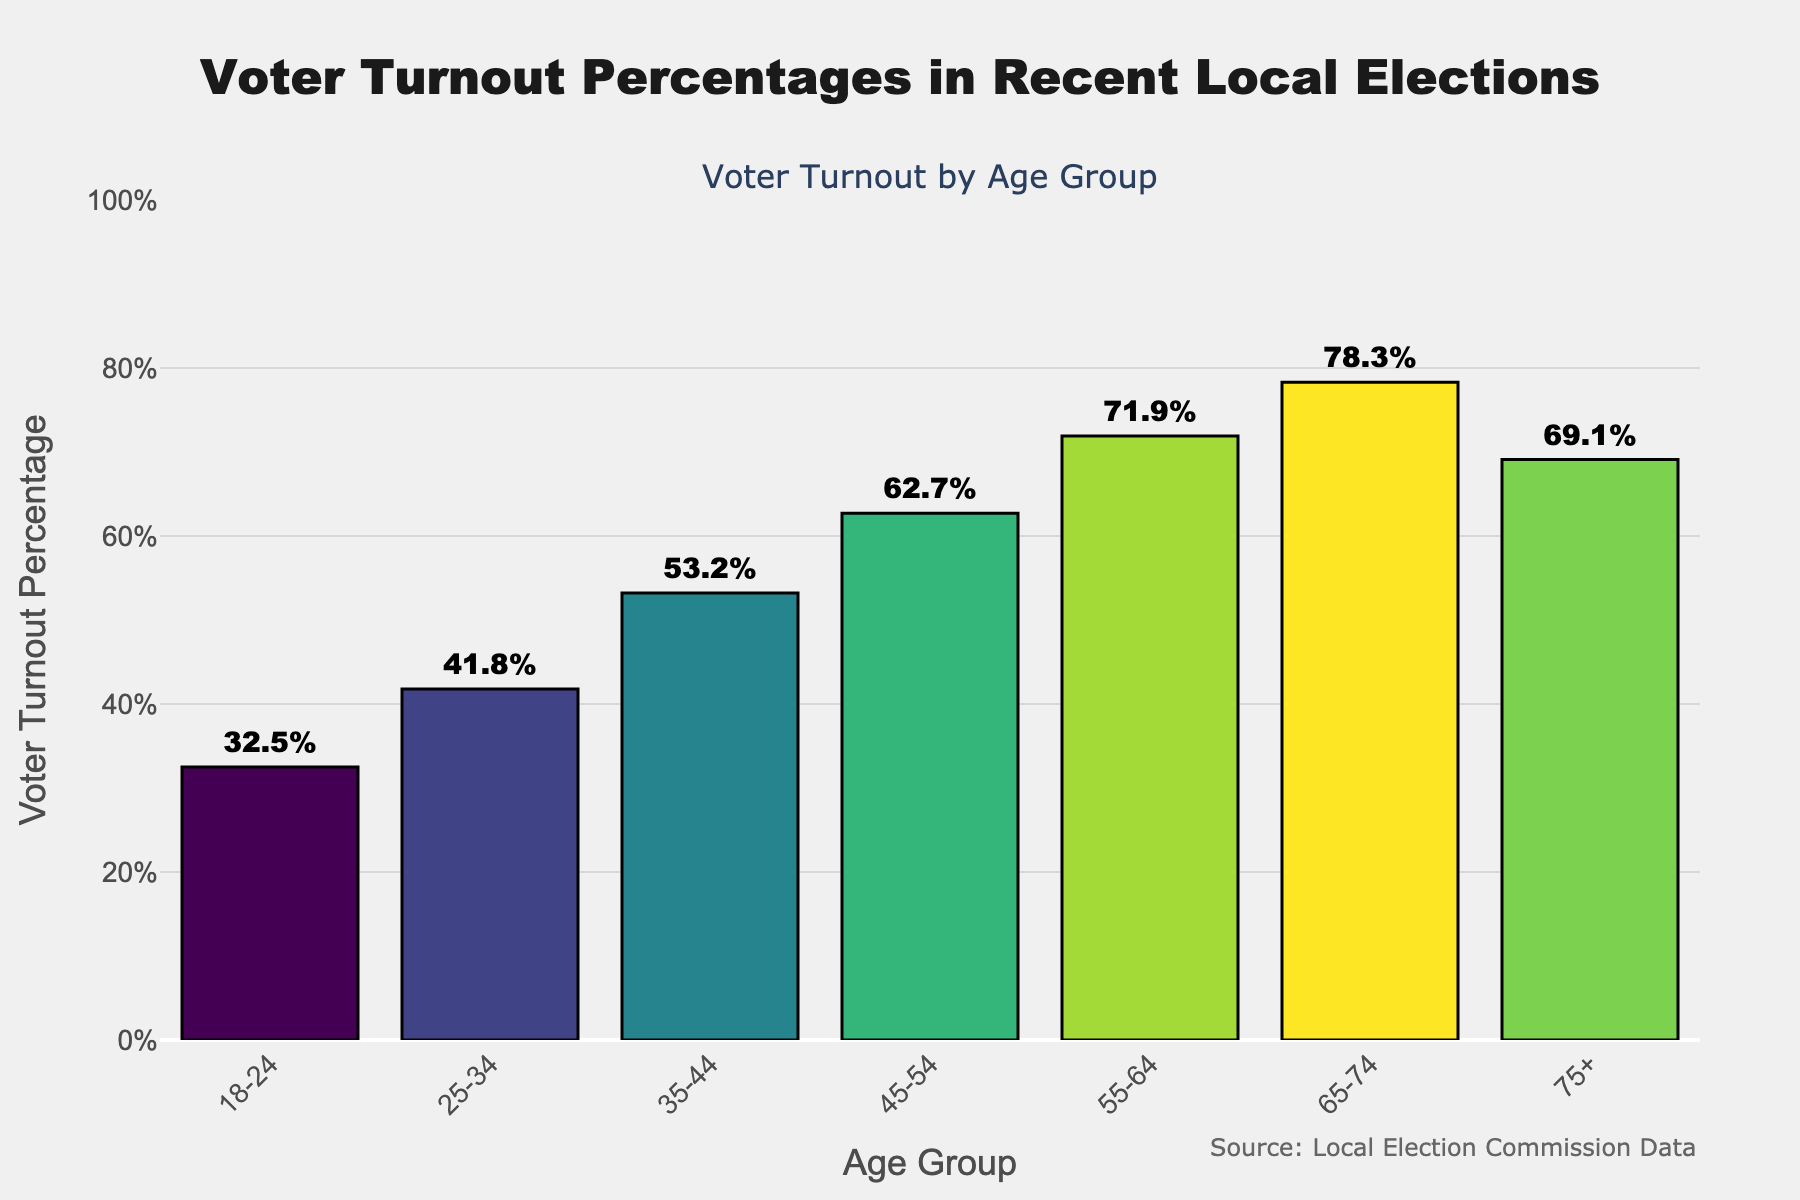Which age group has the highest voter turnout percentage? The chart shows a bar for each age group. The bar for the age group "65-74" reaches the highest value.
Answer: 65-74 Which age group has a voter turnout percentage closest to 50%? By visually comparing the heights of the bars, the age group "35-44" has a turnout percentage of 53.2%, which is closest to 50%.
Answer: 35-44 How much higher is the voter turnout percentage in the 65-74 age group compared to the 18-24 age group? The voter turnout for the 65-74 age group is 78.3%, and for the 18-24 age group, it is 32.5%. The difference is calculated as 78.3% - 32.5% = 45.8%.
Answer: 45.8% What is the average voter turnout percentage for all age groups? To find the average, sum the voter turnout percentages of all age groups and divide by the number of groups. The total is 32.5 + 41.8 + 53.2 + 62.7 + 71.9 + 78.3 + 69.1 = 409.5, and there are 7 groups. So, the average is 409.5 / 7 ≈ 58.5%.
Answer: 58.5% Which age group has a voter turnout percentage lower than 50%? The bars for the 18-24 and 25-34 age groups are below the 50% mark.
Answer: 18-24 and 25-34 By how much does the voter turnout percentage increase from the 25-34 age group to the 55-64 age group? The voter turnout for the 25-34 age group is 41.8%, and for the 55-64 age group, it is 71.9%. The increase is 71.9% - 41.8% = 30.1%.
Answer: 30.1% Which two consecutive age groups have the smallest difference in voter turnout percentage? By comparing the differences between consecutive age groups: 25-34 (41.8%) to 35-44 (53.2%) is 11.4%, 35-44 (53.2%) to 45-54 (62.7%) is 9.5%, 45-54 (62.7%) to 55-64 (71.9%) is 9.2%, 55-64 (71.9%) to 65-74 (78.3%) is 6.4%, and 65-74 (78.3%) to 75+ (69.1%) is 9.2%. The smallest difference is 6.4% between 55-64 and 65-74.
Answer: 55-64 and 65-74 What is the median voter turnout percentage for the age groups? To find the median, the percentages in sorted order are: 32.5, 41.8, 53.2, 62.7, 69.1, 71.9, 78.3. The middle value (4th in the list) is 62.7%.
Answer: 62.7% How does the voter turnout percentage change trend as age groups increase from 18-24 to 65-74? The trend shows a generally increasing pattern in voter turnout percentages as age groups increase from 18-24 (32.5%) to 65-74 (78.3%), before dipping at 75+ (69.1%).
Answer: Increasing, then slightly decreasing What is the voter turnout percentage for the 75+ age group, and how does it compare to the 65-74 age group? The voter turnout for the 75+ age group is 69.1% while the 65-74 age group is 78.3%. The turnout in the 75+ age group is 9.2 percentage points lower than the 65-74.
Answer: 69.1%, 9.2% lower 